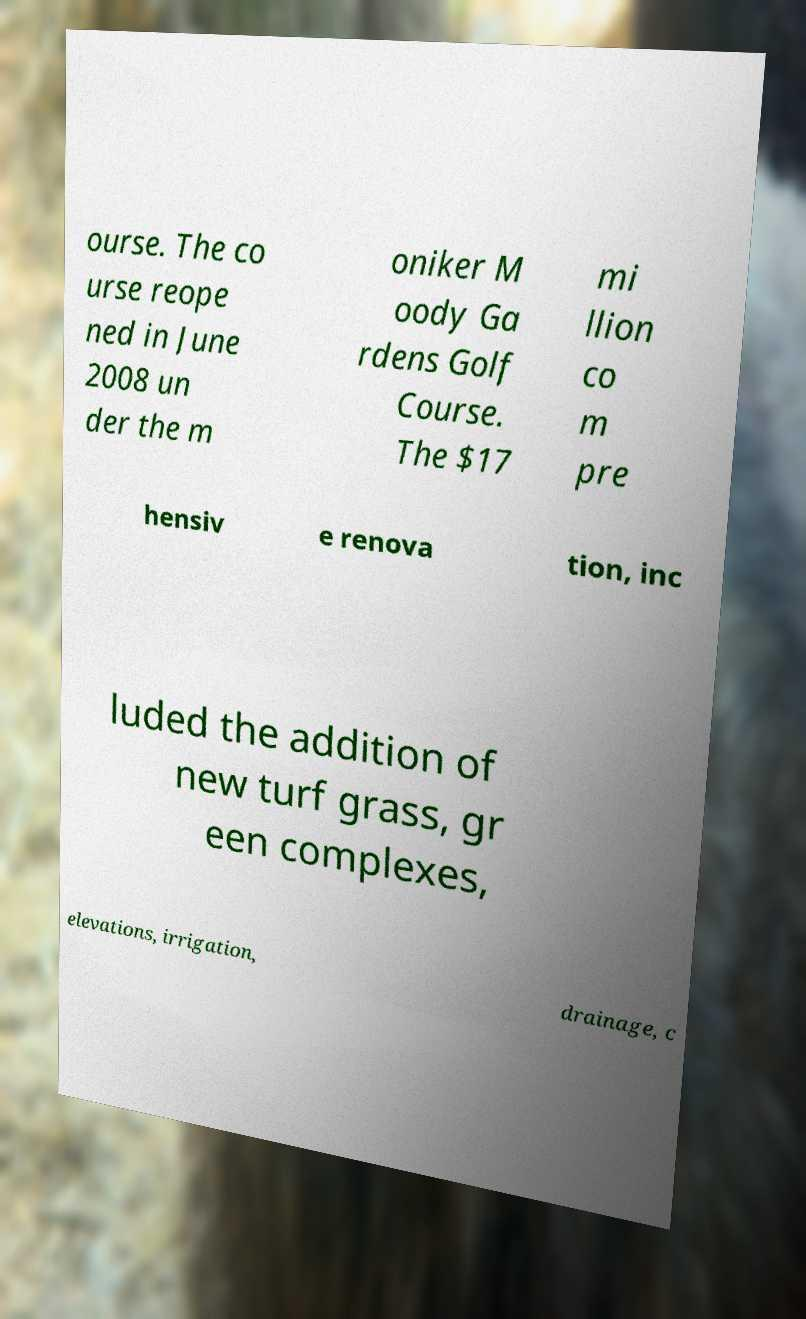Please read and relay the text visible in this image. What does it say? ourse. The co urse reope ned in June 2008 un der the m oniker M oody Ga rdens Golf Course. The $17 mi llion co m pre hensiv e renova tion, inc luded the addition of new turf grass, gr een complexes, elevations, irrigation, drainage, c 